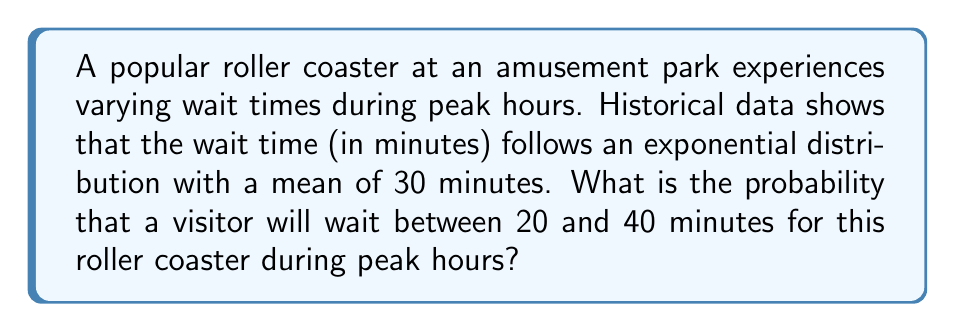Can you solve this math problem? Let's approach this step-by-step:

1) The wait time follows an exponential distribution with a mean of 30 minutes. For an exponential distribution, the rate parameter $\lambda$ is the inverse of the mean. So:

   $\lambda = \frac{1}{\text{mean}} = \frac{1}{30} = 0.0333$ (rounded to 4 decimal places)

2) The cumulative distribution function (CDF) of an exponential distribution is given by:

   $F(x) = 1 - e^{-\lambda x}$

3) We want to find $P(20 < X < 40)$, which is equivalent to $F(40) - F(20)$

4) Let's calculate $F(40)$:
   
   $F(40) = 1 - e^{-0.0333 \times 40} = 1 - e^{-1.332} = 0.7364$ (rounded to 4 decimal places)

5) Now, let's calculate $F(20)$:
   
   $F(20) = 1 - e^{-0.0333 \times 20} = 1 - e^{-0.666} = 0.4866$ (rounded to 4 decimal places)

6) The probability we're looking for is:

   $P(20 < X < 40) = F(40) - F(20) = 0.7364 - 0.4866 = 0.2498$

Therefore, the probability that a visitor will wait between 20 and 40 minutes is approximately 0.2498 or 24.98%.
Answer: 0.2498 